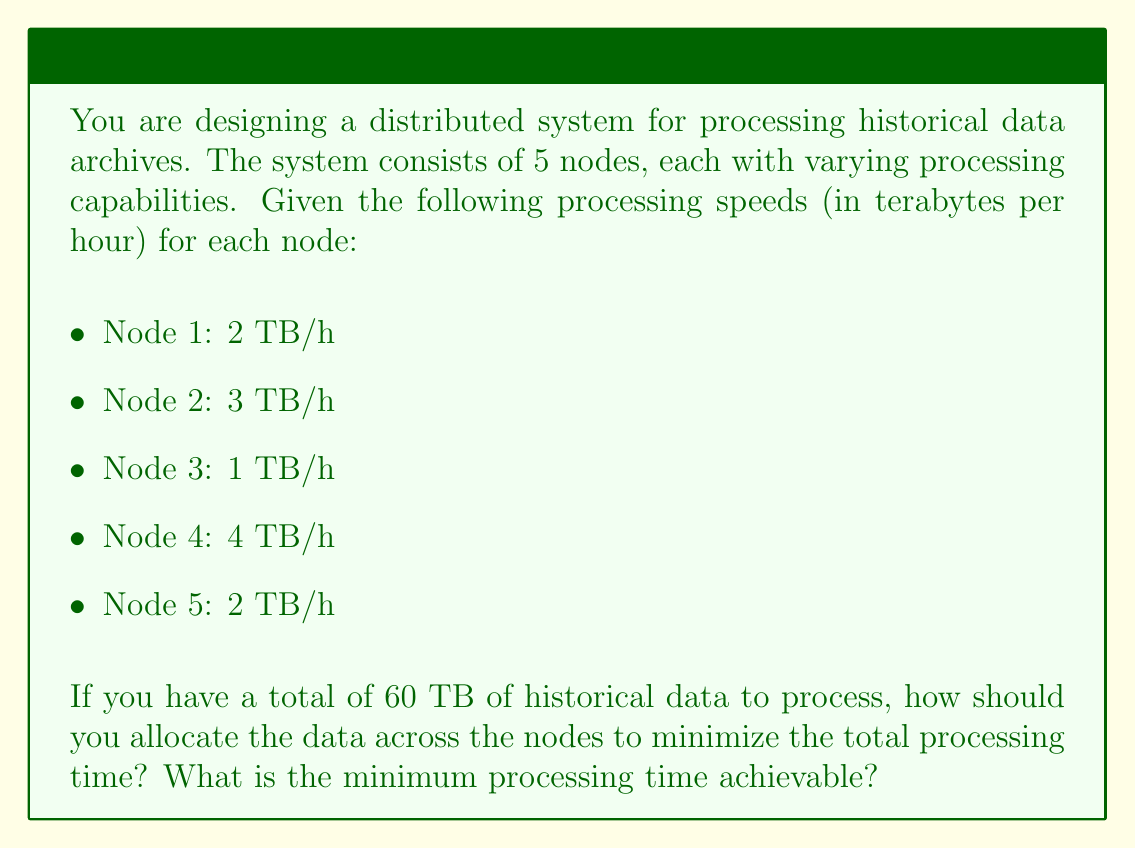Can you solve this math problem? To optimize the resource allocation and minimize the total processing time, we need to use the concept of load balancing in distributed systems. The key is to distribute the workload in such a way that all nodes finish processing at the same time. This approach ensures that no node is idle while others are still working.

Let's solve this step by step:

1) First, calculate the total processing capacity of the system:
   $$ \text{Total Capacity} = 2 + 3 + 1 + 4 + 2 = 12 \text{ TB/h} $$

2) If we distribute the load optimally, all nodes will finish at the same time. Let's call this optimal time $t$. Then:

   $$ 2t + 3t + t + 4t + 2t = 60 \text{ TB} $$
   $$ 12t = 60 \text{ TB} $$
   $$ t = 5 \text{ hours} $$

3) Now, we can calculate how much data each node should process:

   Node 1: $2 \text{ TB/h} \times 5 \text{ h} = 10 \text{ TB}$
   Node 2: $3 \text{ TB/h} \times 5 \text{ h} = 15 \text{ TB}$
   Node 3: $1 \text{ TB/h} \times 5 \text{ h} = 5 \text{ TB}$
   Node 4: $4 \text{ TB/h} \times 5 \text{ h} = 20 \text{ TB}$
   Node 5: $2 \text{ TB/h} \times 5 \text{ h} = 10 \text{ TB}$

4) Verify that the sum of allocated data equals the total data:
   $$ 10 + 15 + 5 + 20 + 10 = 60 \text{ TB} $$

This allocation ensures that all nodes finish processing simultaneously after 5 hours, which is the minimum possible processing time.
Answer: Optimal data allocation:
Node 1: 10 TB
Node 2: 15 TB
Node 3: 5 TB
Node 4: 20 TB
Node 5: 10 TB

Minimum processing time: 5 hours 